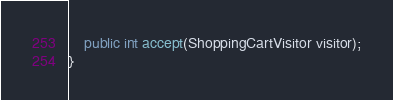<code> <loc_0><loc_0><loc_500><loc_500><_Java_>
	public int accept(ShoppingCartVisitor visitor);
}
</code> 